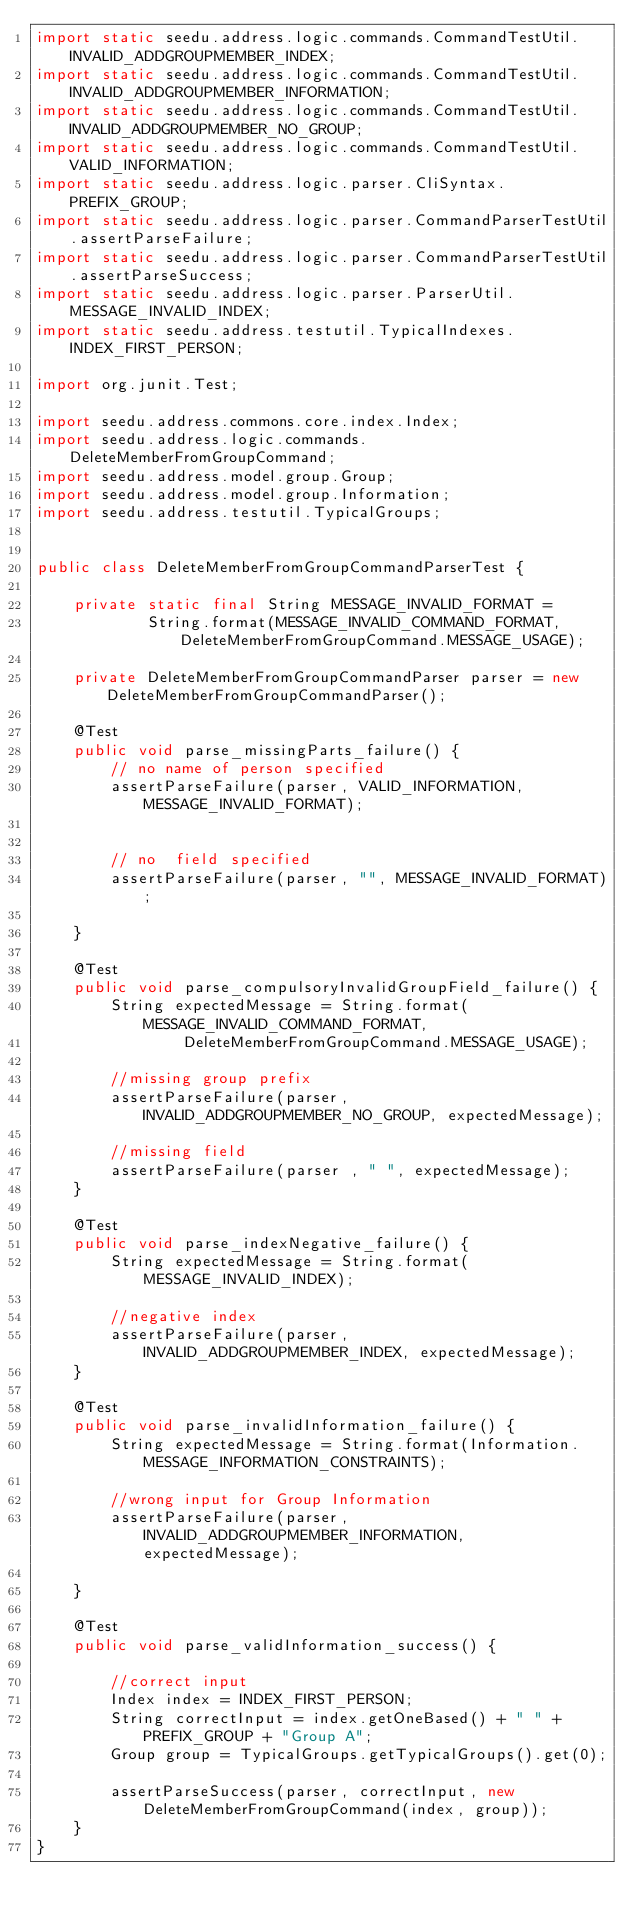<code> <loc_0><loc_0><loc_500><loc_500><_Java_>import static seedu.address.logic.commands.CommandTestUtil.INVALID_ADDGROUPMEMBER_INDEX;
import static seedu.address.logic.commands.CommandTestUtil.INVALID_ADDGROUPMEMBER_INFORMATION;
import static seedu.address.logic.commands.CommandTestUtil.INVALID_ADDGROUPMEMBER_NO_GROUP;
import static seedu.address.logic.commands.CommandTestUtil.VALID_INFORMATION;
import static seedu.address.logic.parser.CliSyntax.PREFIX_GROUP;
import static seedu.address.logic.parser.CommandParserTestUtil.assertParseFailure;
import static seedu.address.logic.parser.CommandParserTestUtil.assertParseSuccess;
import static seedu.address.logic.parser.ParserUtil.MESSAGE_INVALID_INDEX;
import static seedu.address.testutil.TypicalIndexes.INDEX_FIRST_PERSON;

import org.junit.Test;

import seedu.address.commons.core.index.Index;
import seedu.address.logic.commands.DeleteMemberFromGroupCommand;
import seedu.address.model.group.Group;
import seedu.address.model.group.Information;
import seedu.address.testutil.TypicalGroups;


public class DeleteMemberFromGroupCommandParserTest {

    private static final String MESSAGE_INVALID_FORMAT =
            String.format(MESSAGE_INVALID_COMMAND_FORMAT, DeleteMemberFromGroupCommand.MESSAGE_USAGE);

    private DeleteMemberFromGroupCommandParser parser = new DeleteMemberFromGroupCommandParser();

    @Test
    public void parse_missingParts_failure() {
        // no name of person specified
        assertParseFailure(parser, VALID_INFORMATION, MESSAGE_INVALID_FORMAT);


        // no  field specified
        assertParseFailure(parser, "", MESSAGE_INVALID_FORMAT);

    }

    @Test
    public void parse_compulsoryInvalidGroupField_failure() {
        String expectedMessage = String.format(MESSAGE_INVALID_COMMAND_FORMAT,
                DeleteMemberFromGroupCommand.MESSAGE_USAGE);

        //missing group prefix
        assertParseFailure(parser, INVALID_ADDGROUPMEMBER_NO_GROUP, expectedMessage);

        //missing field
        assertParseFailure(parser , " ", expectedMessage);
    }

    @Test
    public void parse_indexNegative_failure() {
        String expectedMessage = String.format(MESSAGE_INVALID_INDEX);

        //negative index
        assertParseFailure(parser, INVALID_ADDGROUPMEMBER_INDEX, expectedMessage);
    }

    @Test
    public void parse_invalidInformation_failure() {
        String expectedMessage = String.format(Information.MESSAGE_INFORMATION_CONSTRAINTS);

        //wrong input for Group Information
        assertParseFailure(parser, INVALID_ADDGROUPMEMBER_INFORMATION, expectedMessage);

    }

    @Test
    public void parse_validInformation_success() {

        //correct input
        Index index = INDEX_FIRST_PERSON;
        String correctInput = index.getOneBased() + " " + PREFIX_GROUP + "Group A";
        Group group = TypicalGroups.getTypicalGroups().get(0);

        assertParseSuccess(parser, correctInput, new DeleteMemberFromGroupCommand(index, group));
    }
}
</code> 